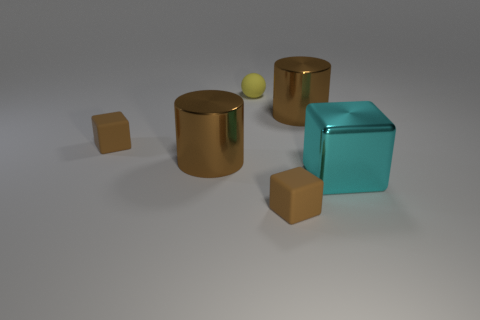Is the number of brown objects that are right of the small yellow sphere less than the number of blue shiny blocks?
Provide a short and direct response. No. There is a large brown metallic thing to the left of the big brown cylinder to the right of the brown thing in front of the large metal cube; what is its shape?
Give a very brief answer. Cylinder. Is the cyan metallic object the same shape as the yellow object?
Provide a short and direct response. No. What number of other objects are the same shape as the yellow object?
Make the answer very short. 0. Is the number of large shiny cylinders on the right side of the small yellow ball the same as the number of cyan shiny objects?
Offer a terse response. Yes. There is a big shiny thing that is both to the right of the yellow matte object and to the left of the cyan metallic thing; what shape is it?
Provide a succinct answer. Cylinder. Is the yellow object the same size as the cyan metal cube?
Keep it short and to the point. No. Are there any large things made of the same material as the big cyan cube?
Ensure brevity in your answer.  Yes. What number of brown things are to the left of the tiny yellow thing and in front of the big cyan metallic thing?
Your answer should be compact. 0. There is a large brown cylinder on the left side of the yellow object; what material is it?
Provide a succinct answer. Metal. 